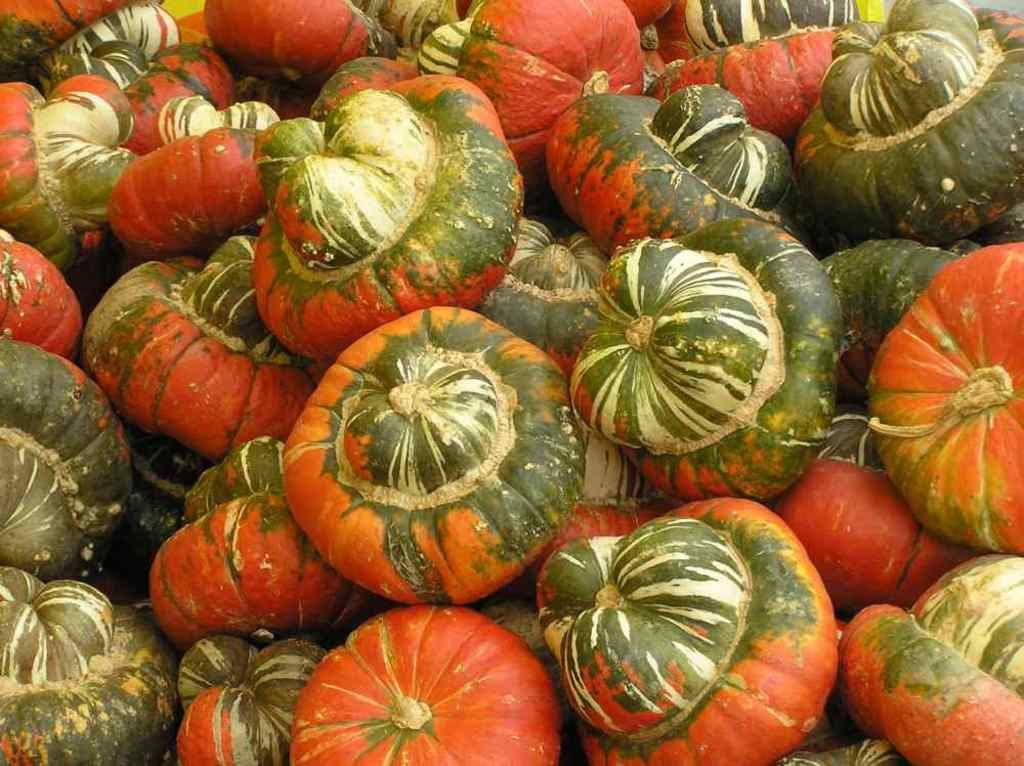What type of objects are predominantly featured in the image? There are many pumpkins in the image. Can you describe the color and shape of the pumpkins? The pumpkins are typically orange in color and round in shape. Are there any other objects or elements present in the image besides the pumpkins? The provided facts do not mention any other objects or elements in the image. What type of health advice can be found in the image? There is no health advice present in the image, as it only features pumpkins. Is there a church visible in the image? There is no church present in the image, as it only features pumpkins. 